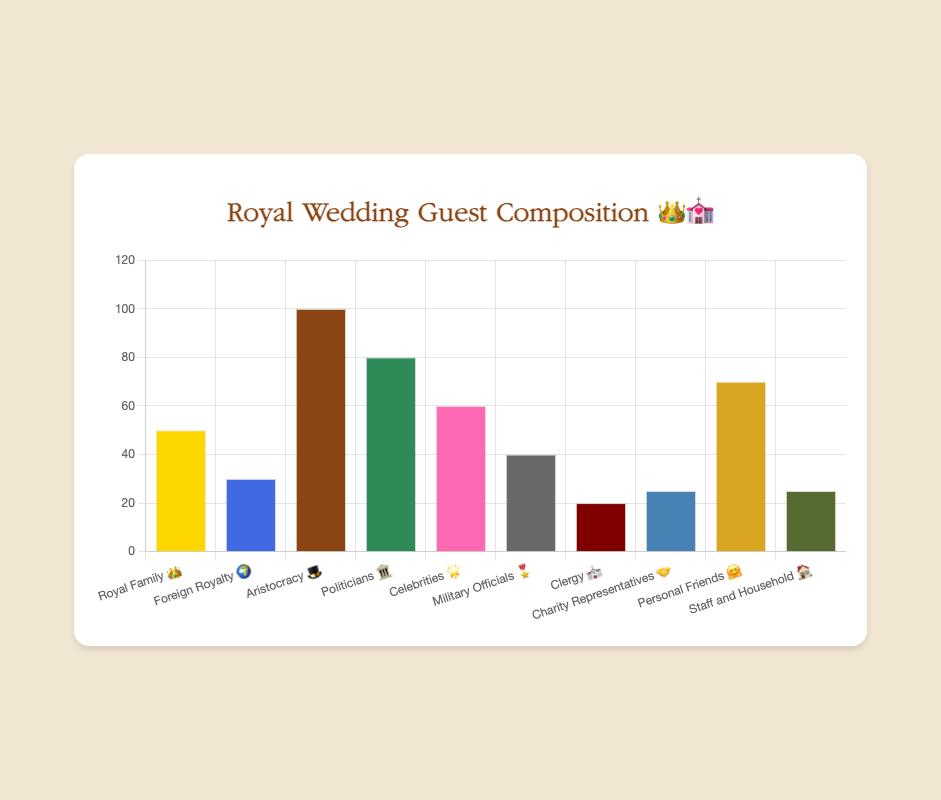What's the total number of guests invited to the royal wedding? Sum the numbers of all categories: 50 (Royal Family) + 30 (Foreign Royalty) + 100 (Aristocracy) + 80 (Politicians) + 60 (Celebrities) + 40 (Military Officials) + 20 (Clergy) + 25 (Charity Representatives) + 70 (Personal Friends) + 25 (Staff and Household) = 500
Answer: 500 Which group has the highest number of guests? Identify the category with the largest value from the data: Aristocracy (100)
Answer: Aristocracy Which two groups have the same number of guests? Identify equal values in the data: Charity Representatives (25) and Staff and Household (25)
Answer: Charity Representatives and Staff and Household What's the average number of guests across all groups? Sum the total number of guests (500) and divide by the number of categories (10): 500 / 10 = 50
Answer: 50 How many more guests does the Aristocracy group have compared to the Clergy group? Subtract the number of Clergy guests from Aristocracy guests: 100 - 20 = 80
Answer: 80 What's the difference in the number of guests between Celebrities and Military Officials? Subtract the number of Military Officials from Celebrities: 60 - 40 = 20
Answer: 20 Which category has the fewest guests? Identify the category with the smallest value from the data: Clergy (20)
Answer: Clergy How many guests are there from the Royal Family and Foreign Royalty combined? Add the number of Royal Family and Foreign Royalty guests: 50 + 30 = 80
Answer: 80 How many categories have more than 50 guests? Identify how many categories have values greater than 50: Aristocracy (100), Politicians (80), Celebrities (60), Personal Friends (70) = 4 categories
Answer: 4 What percentage of the guests are Politicians? Calculate the number of Politicians as a percentage of the total number of guests: (80 / 500) * 100 = 16%
Answer: 16% 